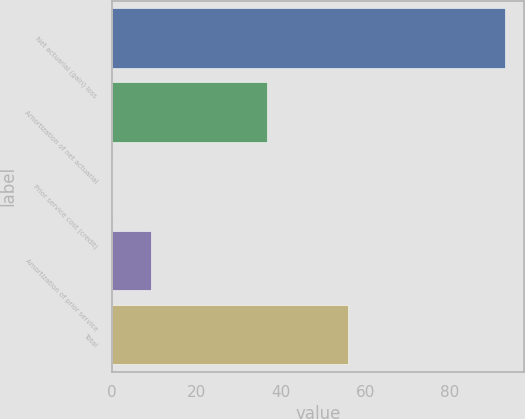Convert chart. <chart><loc_0><loc_0><loc_500><loc_500><bar_chart><fcel>Net actuarial (gain) loss<fcel>Amortization of net actuarial<fcel>Prior service cost (credit)<fcel>Amortization of prior service<fcel>Total<nl><fcel>92.9<fcel>36.8<fcel>0.1<fcel>9.38<fcel>55.8<nl></chart> 